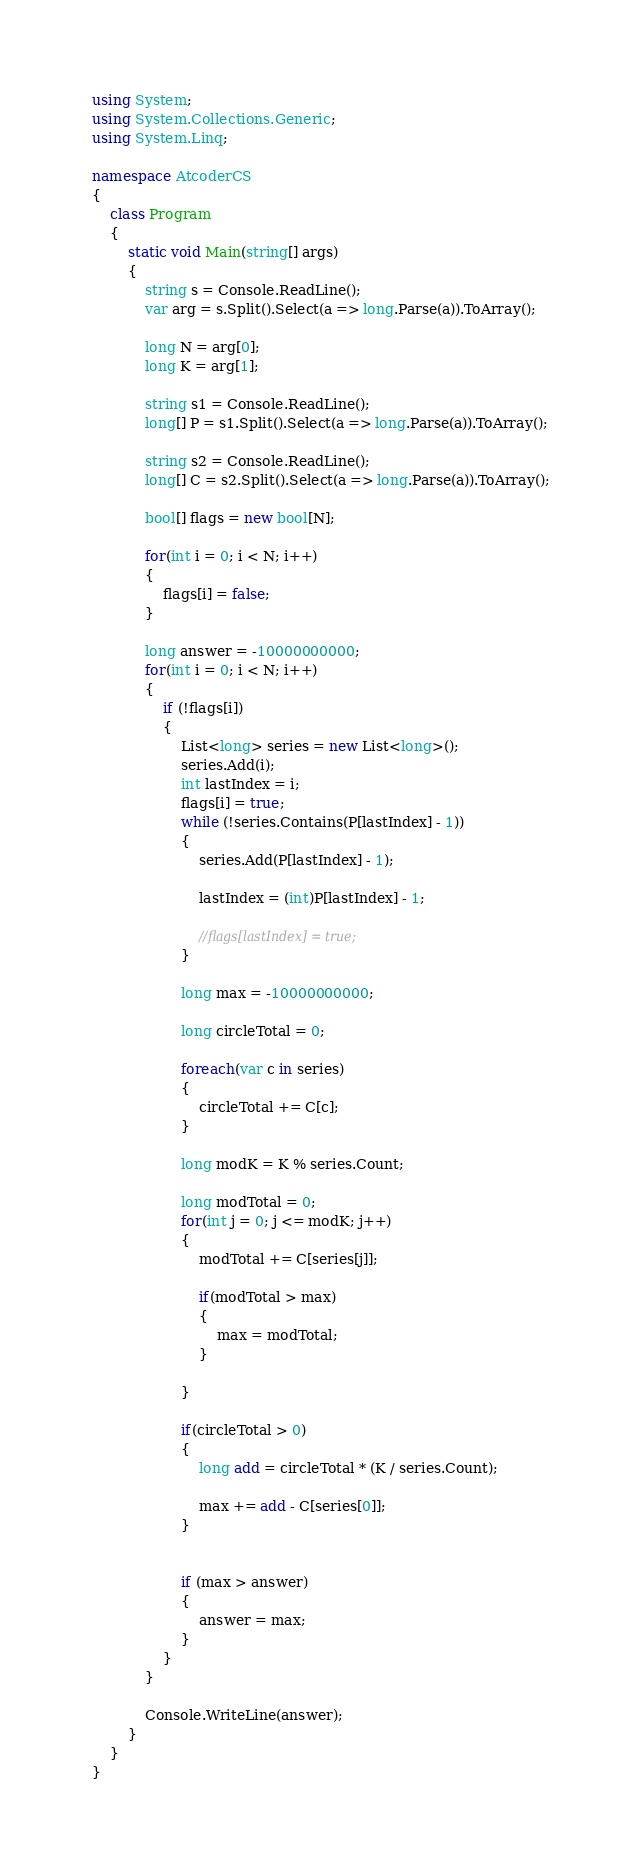Convert code to text. <code><loc_0><loc_0><loc_500><loc_500><_C#_>using System;
using System.Collections.Generic;
using System.Linq;

namespace AtcoderCS
{
    class Program
    {
        static void Main(string[] args)
        {
            string s = Console.ReadLine();
            var arg = s.Split().Select(a => long.Parse(a)).ToArray();

            long N = arg[0];
            long K = arg[1];

            string s1 = Console.ReadLine();
            long[] P = s1.Split().Select(a => long.Parse(a)).ToArray();

            string s2 = Console.ReadLine();
            long[] C = s2.Split().Select(a => long.Parse(a)).ToArray();

            bool[] flags = new bool[N];

            for(int i = 0; i < N; i++)
            {
                flags[i] = false;
            }

            long answer = -10000000000;
            for(int i = 0; i < N; i++)
            {
                if (!flags[i])
                {
                    List<long> series = new List<long>();
                    series.Add(i);
                    int lastIndex = i;
                    flags[i] = true;
                    while (!series.Contains(P[lastIndex] - 1))
                    {
                        series.Add(P[lastIndex] - 1);

                        lastIndex = (int)P[lastIndex] - 1;

                        //flags[lastIndex] = true;
                    }

                    long max = -10000000000;

                    long circleTotal = 0;

                    foreach(var c in series)
                    {
                        circleTotal += C[c];
                    }

                    long modK = K % series.Count;

                    long modTotal = 0;
                    for(int j = 0; j <= modK; j++)
                    {
                        modTotal += C[series[j]];

                        if(modTotal > max)
                        {
                            max = modTotal;
                        }

                    }

                    if(circleTotal > 0)
                    {
                        long add = circleTotal * (K / series.Count);

                        max += add - C[series[0]];
                    }


                    if (max > answer)
                    {
                        answer = max;
                    }
                }
            }

            Console.WriteLine(answer);
        }
    }
}
</code> 